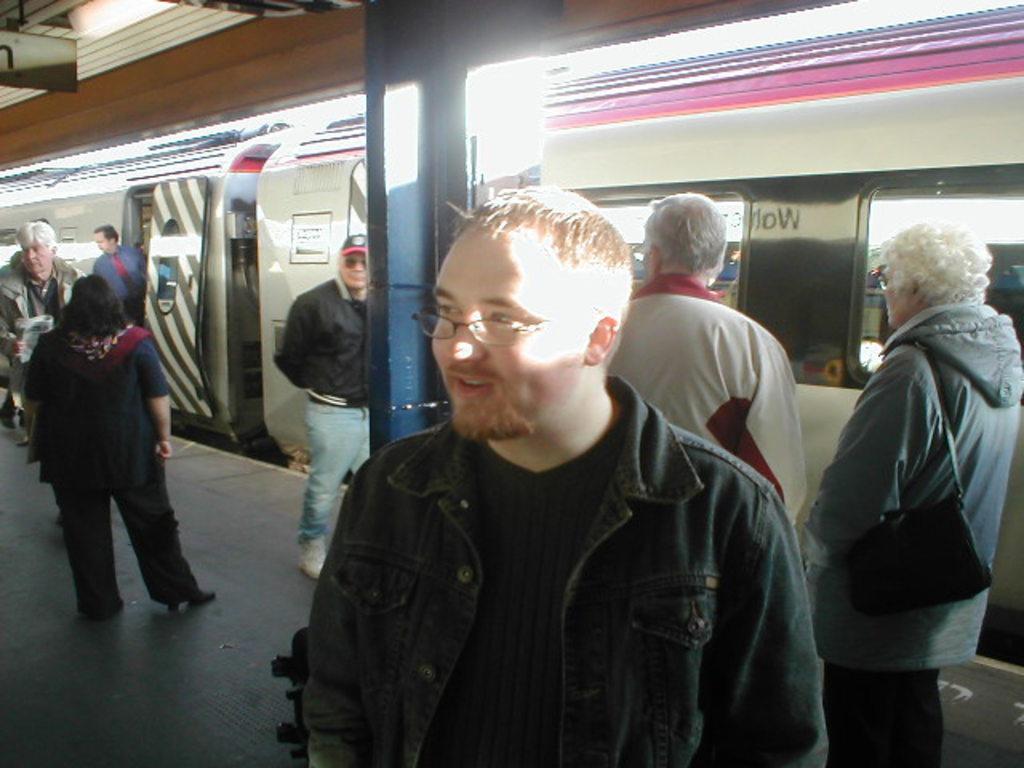How would you summarize this image in a sentence or two? There are few people standing. I think this is the platform. Here is the train. This looks like an iron pillar. I think this is a board. 